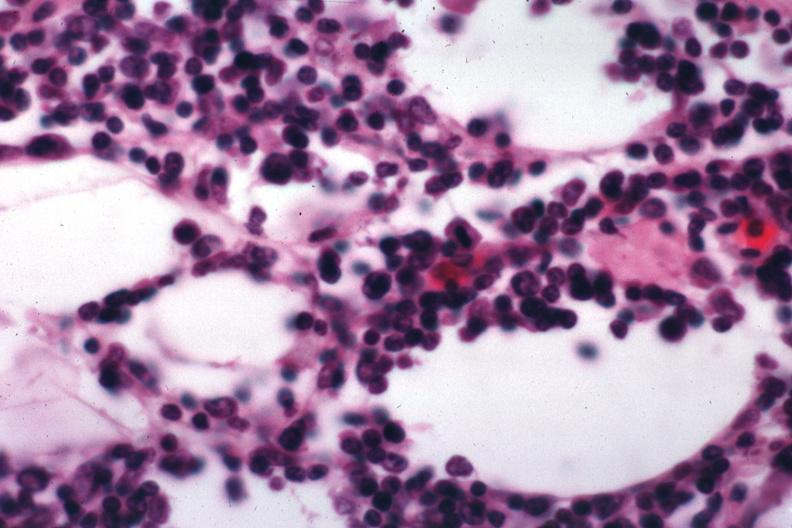does this image show lymphocytic infiltration in perinodal fat?
Answer the question using a single word or phrase. Yes 